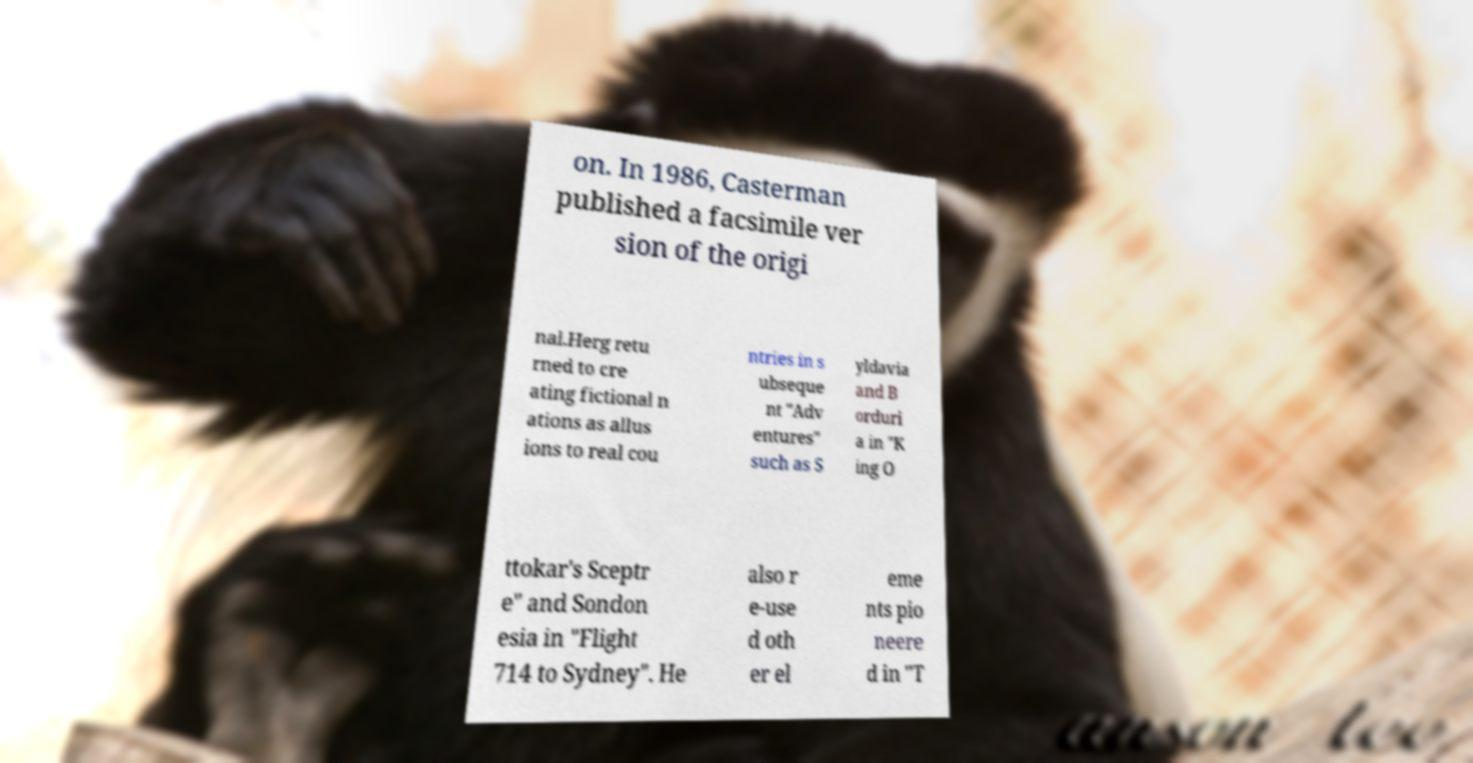What messages or text are displayed in this image? I need them in a readable, typed format. on. In 1986, Casterman published a facsimile ver sion of the origi nal.Herg retu rned to cre ating fictional n ations as allus ions to real cou ntries in s ubseque nt "Adv entures" such as S yldavia and B orduri a in "K ing O ttokar's Sceptr e" and Sondon esia in "Flight 714 to Sydney". He also r e-use d oth er el eme nts pio neere d in "T 